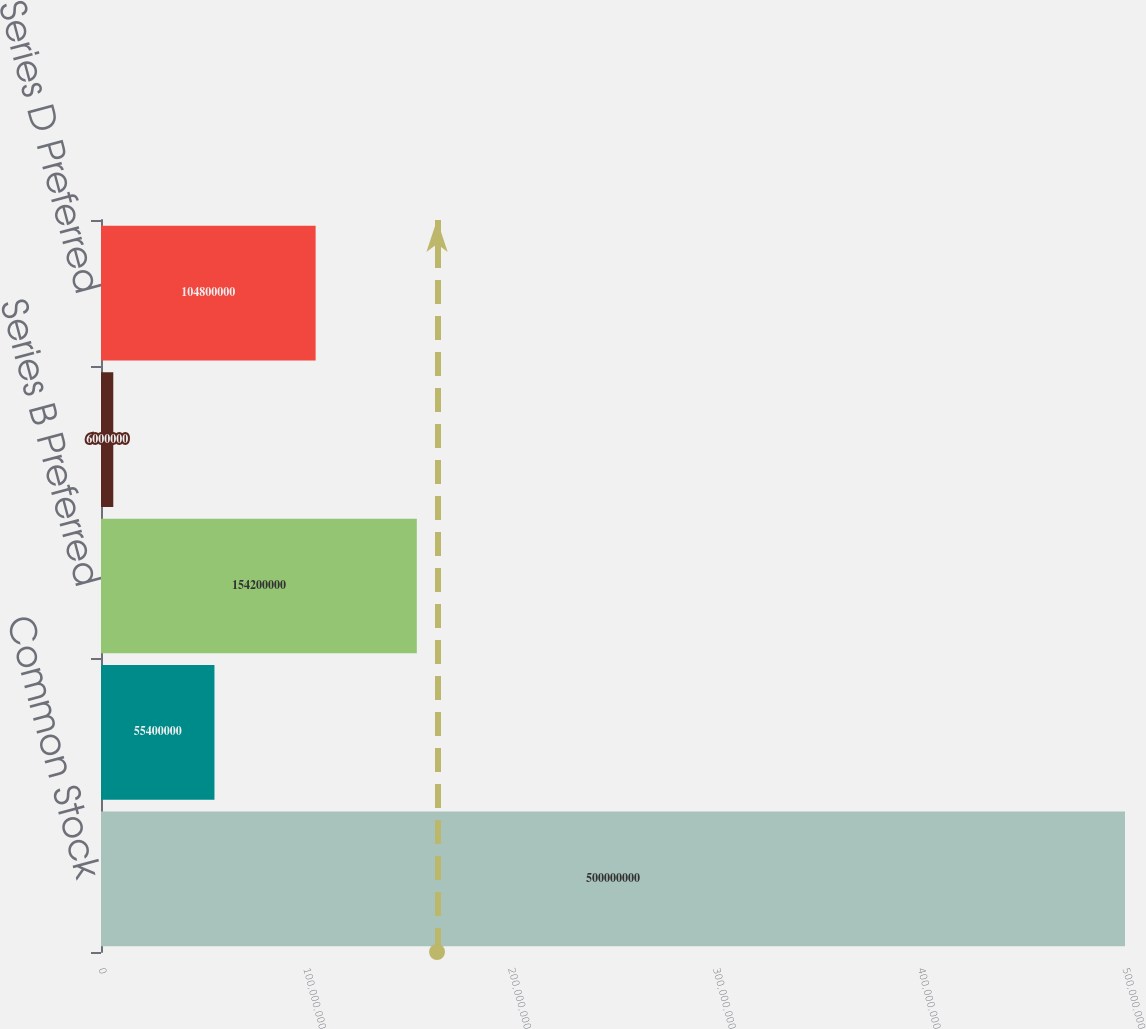<chart> <loc_0><loc_0><loc_500><loc_500><bar_chart><fcel>Common Stock<fcel>Series A Preferred<fcel>Series B Preferred<fcel>Series C Preferred<fcel>Series D Preferred<nl><fcel>5e+08<fcel>5.54e+07<fcel>1.542e+08<fcel>6e+06<fcel>1.048e+08<nl></chart> 